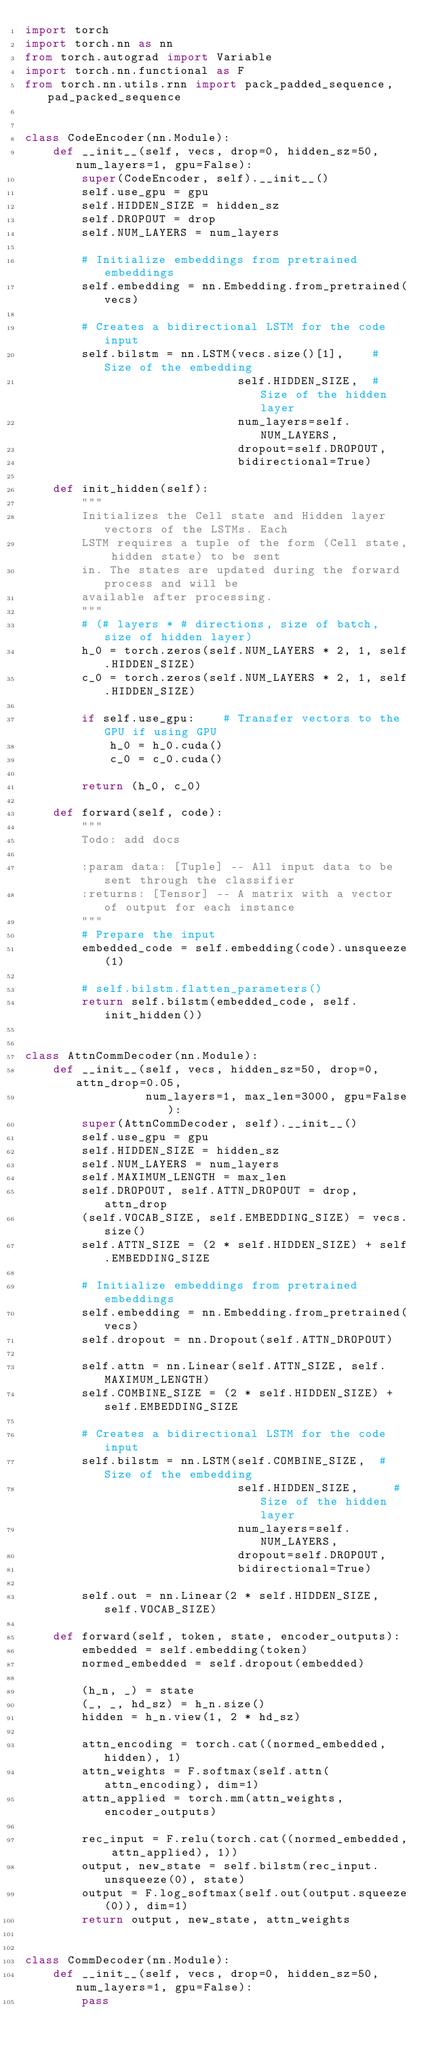<code> <loc_0><loc_0><loc_500><loc_500><_Python_>import torch
import torch.nn as nn
from torch.autograd import Variable
import torch.nn.functional as F
from torch.nn.utils.rnn import pack_padded_sequence, pad_packed_sequence


class CodeEncoder(nn.Module):
    def __init__(self, vecs, drop=0, hidden_sz=50, num_layers=1, gpu=False):
        super(CodeEncoder, self).__init__()
        self.use_gpu = gpu
        self.HIDDEN_SIZE = hidden_sz
        self.DROPOUT = drop
        self.NUM_LAYERS = num_layers

        # Initialize embeddings from pretrained embeddings
        self.embedding = nn.Embedding.from_pretrained(vecs)

        # Creates a bidirectional LSTM for the code input
        self.bilstm = nn.LSTM(vecs.size()[1],    # Size of the embedding
                              self.HIDDEN_SIZE,  # Size of the hidden layer
                              num_layers=self.NUM_LAYERS,
                              dropout=self.DROPOUT,
                              bidirectional=True)

    def init_hidden(self):
        """
        Initializes the Cell state and Hidden layer vectors of the LSTMs. Each
        LSTM requires a tuple of the form (Cell state, hidden state) to be sent
        in. The states are updated during the forward process and will be
        available after processing.
        """
        # (# layers * # directions, size of batch, size of hidden layer)
        h_0 = torch.zeros(self.NUM_LAYERS * 2, 1, self.HIDDEN_SIZE)
        c_0 = torch.zeros(self.NUM_LAYERS * 2, 1, self.HIDDEN_SIZE)

        if self.use_gpu:    # Transfer vectors to the GPU if using GPU
            h_0 = h_0.cuda()
            c_0 = c_0.cuda()

        return (h_0, c_0)

    def forward(self, code):
        """
        Todo: add docs

        :param data: [Tuple] -- All input data to be sent through the classifier
        :returns: [Tensor] -- A matrix with a vector of output for each instance
        """
        # Prepare the input
        embedded_code = self.embedding(code).unsqueeze(1)

        # self.bilstm.flatten_parameters()
        return self.bilstm(embedded_code, self.init_hidden())


class AttnCommDecoder(nn.Module):
    def __init__(self, vecs, hidden_sz=50, drop=0, attn_drop=0.05,
                 num_layers=1, max_len=3000, gpu=False):
        super(AttnCommDecoder, self).__init__()
        self.use_gpu = gpu
        self.HIDDEN_SIZE = hidden_sz
        self.NUM_LAYERS = num_layers
        self.MAXIMUM_LENGTH = max_len
        self.DROPOUT, self.ATTN_DROPOUT = drop, attn_drop
        (self.VOCAB_SIZE, self.EMBEDDING_SIZE) = vecs.size()
        self.ATTN_SIZE = (2 * self.HIDDEN_SIZE) + self.EMBEDDING_SIZE

        # Initialize embeddings from pretrained embeddings
        self.embedding = nn.Embedding.from_pretrained(vecs)
        self.dropout = nn.Dropout(self.ATTN_DROPOUT)

        self.attn = nn.Linear(self.ATTN_SIZE, self.MAXIMUM_LENGTH)
        self.COMBINE_SIZE = (2 * self.HIDDEN_SIZE) + self.EMBEDDING_SIZE

        # Creates a bidirectional LSTM for the code input
        self.bilstm = nn.LSTM(self.COMBINE_SIZE,  # Size of the embedding
                              self.HIDDEN_SIZE,     # Size of the hidden layer
                              num_layers=self.NUM_LAYERS,
                              dropout=self.DROPOUT,
                              bidirectional=True)

        self.out = nn.Linear(2 * self.HIDDEN_SIZE, self.VOCAB_SIZE)

    def forward(self, token, state, encoder_outputs):
        embedded = self.embedding(token)
        normed_embedded = self.dropout(embedded)

        (h_n, _) = state
        (_, _, hd_sz) = h_n.size()
        hidden = h_n.view(1, 2 * hd_sz)

        attn_encoding = torch.cat((normed_embedded, hidden), 1)
        attn_weights = F.softmax(self.attn(attn_encoding), dim=1)
        attn_applied = torch.mm(attn_weights, encoder_outputs)

        rec_input = F.relu(torch.cat((normed_embedded, attn_applied), 1))
        output, new_state = self.bilstm(rec_input.unsqueeze(0), state)
        output = F.log_softmax(self.out(output.squeeze(0)), dim=1)
        return output, new_state, attn_weights


class CommDecoder(nn.Module):
    def __init__(self, vecs, drop=0, hidden_sz=50, num_layers=1, gpu=False):
        pass
</code> 